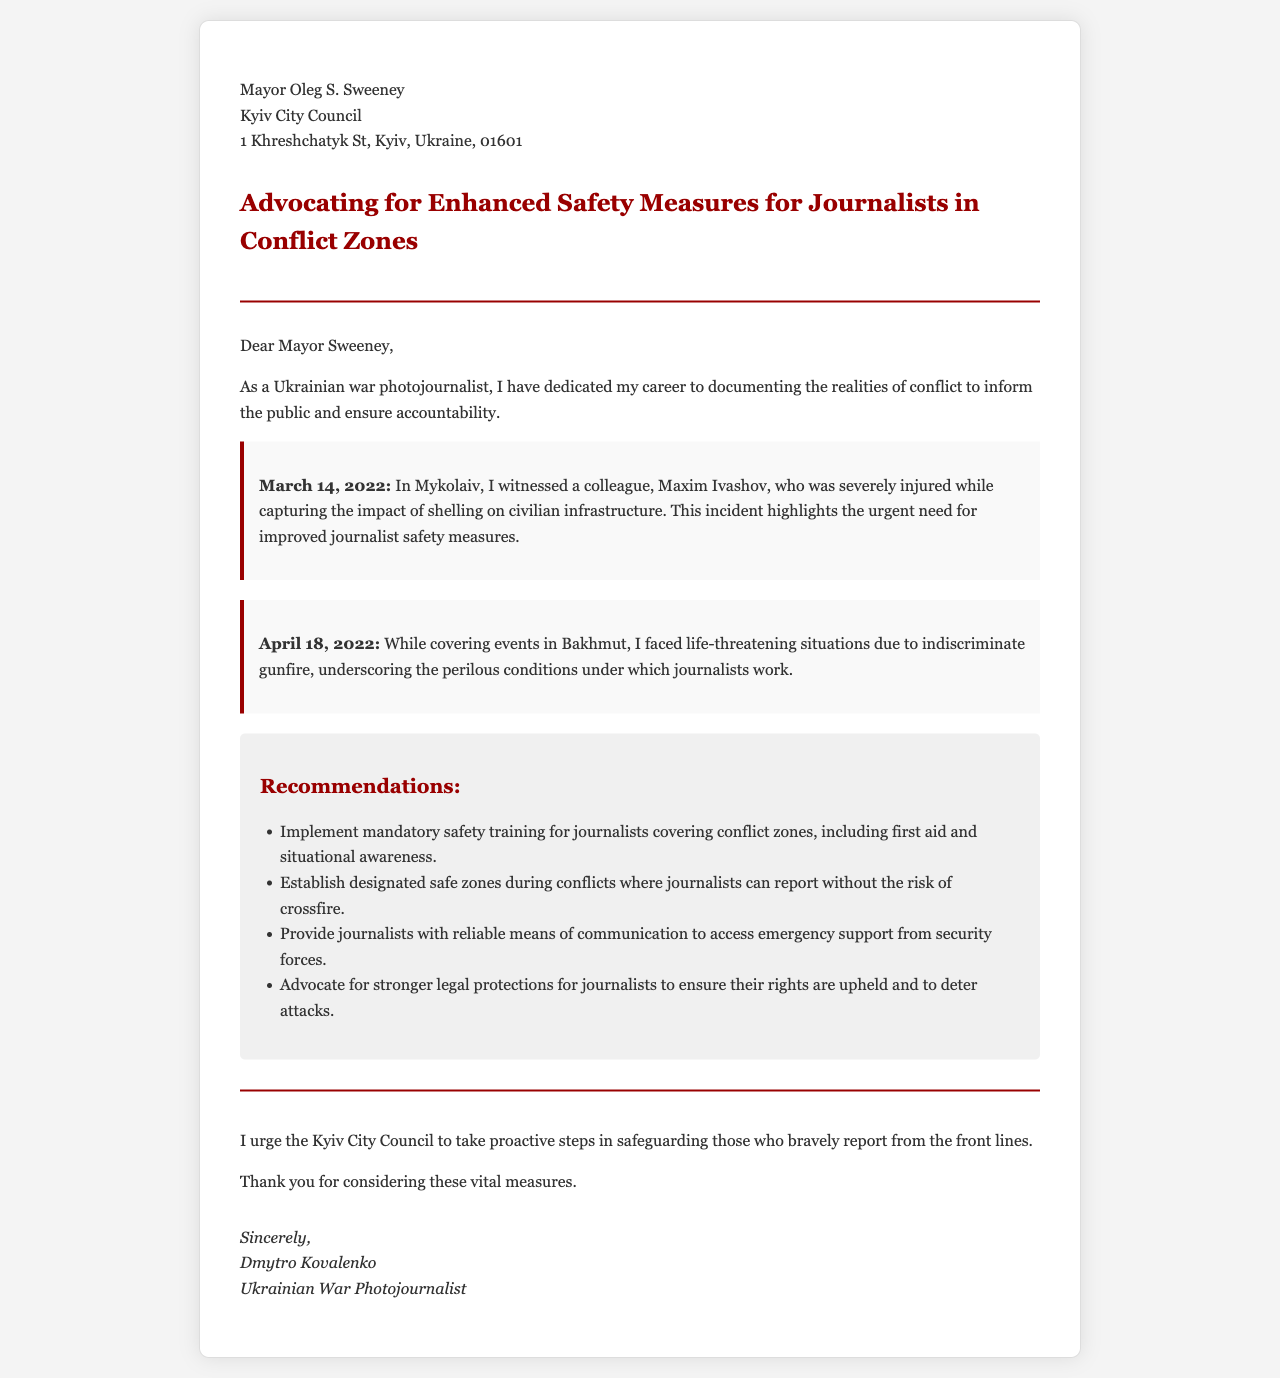What is the date of the incident involving Maxim Ivashov? The incident involving Maxim Ivashov occurred on March 14, 2022, as mentioned in the letter.
Answer: March 14, 2022 Who is the recipient of the letter? The letter is addressed to Mayor Oleg S. Sweeney, as stated at the beginning.
Answer: Mayor Oleg S. Sweeney What are the recommended safety measures for journalists? The letter lists several recommendations, including mandatory safety training and establishing safe zones.
Answer: Mandatory safety training, designated safe zones In what city did the April 18, 2022 incident take place? The April 18, 2022 incident occurred in Bakhmut, as recorded in the document.
Answer: Bakhmut What profession does the author of the letter hold? The author, Dmytro Kovalenko, identifies as a Ukrainian war photojournalist in the introduction.
Answer: Ukrainian war photojournalist What is one of the life-threatening situations mentioned in the document? The document describes life-threatening situations due to indiscriminate gunfire in Bakhmut.
Answer: Indiscriminate gunfire What is the closing statement's primary call to action? The author urges the Kyiv City Council to take proactive steps in safeguarding journalists.
Answer: Safeguarding journalists What type of document is this? The document is a letter advocating for improved safety measures for journalists in conflict zones.
Answer: A letter 